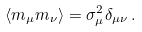Convert formula to latex. <formula><loc_0><loc_0><loc_500><loc_500>\left < m _ { \mu } m _ { \nu } \right > = \sigma _ { \mu } ^ { 2 } \delta _ { \mu \nu } \, .</formula> 